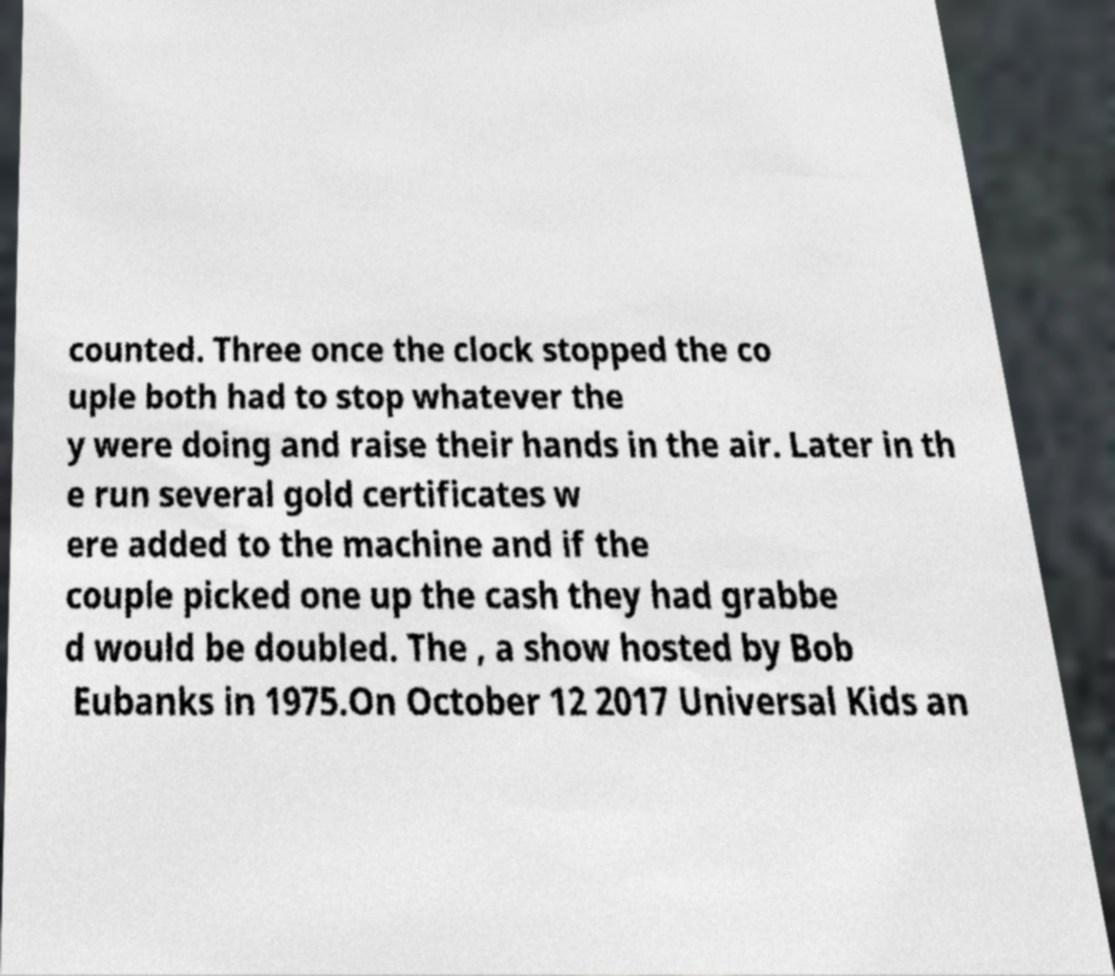I need the written content from this picture converted into text. Can you do that? counted. Three once the clock stopped the co uple both had to stop whatever the y were doing and raise their hands in the air. Later in th e run several gold certificates w ere added to the machine and if the couple picked one up the cash they had grabbe d would be doubled. The , a show hosted by Bob Eubanks in 1975.On October 12 2017 Universal Kids an 